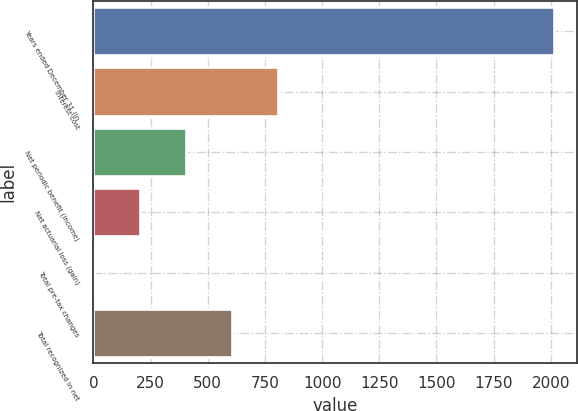Convert chart. <chart><loc_0><loc_0><loc_500><loc_500><bar_chart><fcel>Years ended December 31 (in<fcel>Interest cost<fcel>Net periodic benefit (income)<fcel>Net actuarial loss (gain)<fcel>Total pre-tax changes<fcel>Total recognized in net<nl><fcel>2015<fcel>808.34<fcel>406.12<fcel>205.01<fcel>3.9<fcel>607.23<nl></chart> 